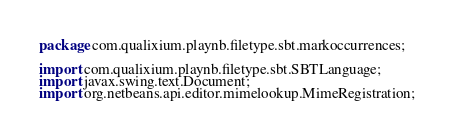<code> <loc_0><loc_0><loc_500><loc_500><_Java_>package com.qualixium.playnb.filetype.sbt.markoccurrences;

import com.qualixium.playnb.filetype.sbt.SBTLanguage;
import javax.swing.text.Document;
import org.netbeans.api.editor.mimelookup.MimeRegistration;</code> 